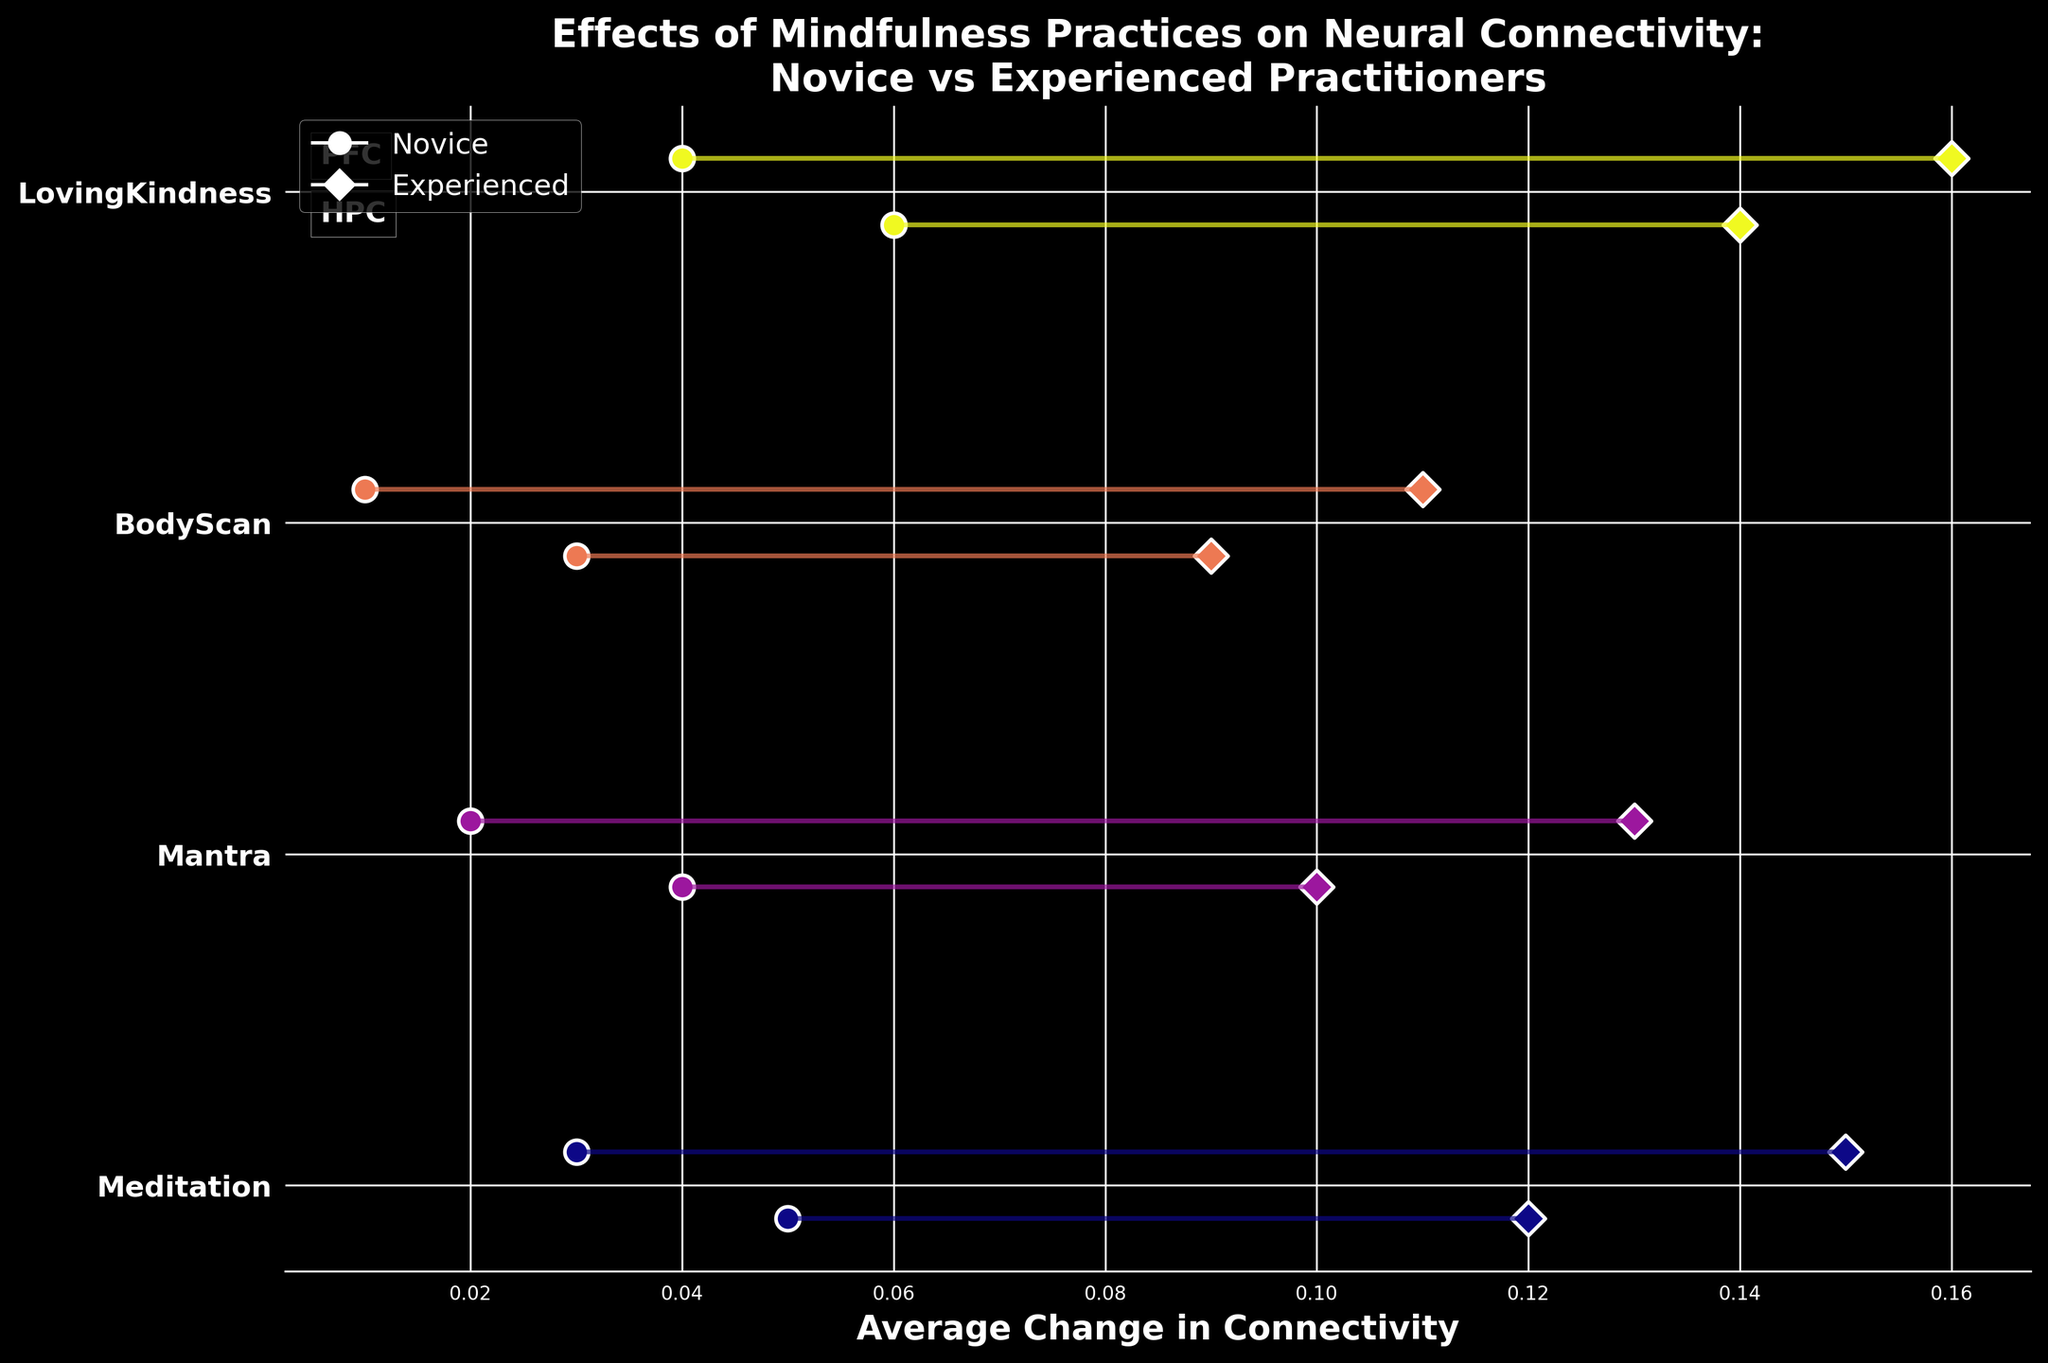How many different mindfulness practices are compared in the figure? The figure shows practices as unique y-axis labels. Counting these labels gives the total number of practices.
Answer: 4 What is the title of the figure? The title is written at the top of the figure.
Answer: Effects of Mindfulness Practices on Neural Connectivity: Novice vs Experienced Practitioners Which mindfulness practice shows the largest increase in neural connectivity for experienced practitioners in the PFC region? Look at the experienced practitioners' markers (diamonds) for different practices in the PFC region, and find the one with the highest value.
Answer: Loving-Kindness What's the difference in connectivity changes between novices and experienced practitioners for the HPC region when practicing Meditation? Find the connectivity changes for both novice and experienced practitioners in the HPC region for Meditation, then subtract the novice value from the experienced value.
Answer: 0.12 Which brain region saw the smallest increase in connectivity for novice practitioners across all practices? Compare the connectivity changes for novice practitioners across all practices and brain regions, and find the smallest value.
Answer: HPC Which practice showed the least difference in connectivity changes between novice and experienced practitioners in the PFC region? Calculate the difference for each practice in the PFC region, then find the smallest difference.
Answer: Body Scan For the practice of Mantra, did novices or experienced practitioners show greater connectivity changes in the HPC region? Compare the connectivity changes in the HPC region for Mantra practice between novices and experienced practitioners.
Answer: Experienced practitioners How does the connectivity change for experienced practitioners in the HPC region compare between Meditation and Body Scan practices? Look at the connectivity changes for experienced practitioners in the HPC region for both Meditation and Body Scan and compare them.
Answer: Meditation has a higher increase What's the average connectivity change for experienced practitioners across all practices in the PFC region? Sum the connectivity changes for experienced practitioners in the PFC region across all practices, then divide by the number of practices.
Answer: (0.12 + 0.10 + 0.09 + 0.14)/4 = 0.11 